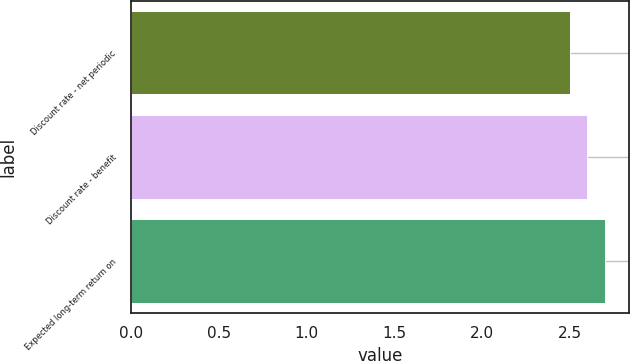Convert chart to OTSL. <chart><loc_0><loc_0><loc_500><loc_500><bar_chart><fcel>Discount rate - net periodic<fcel>Discount rate - benefit<fcel>Expected long-term return on<nl><fcel>2.5<fcel>2.6<fcel>2.7<nl></chart> 